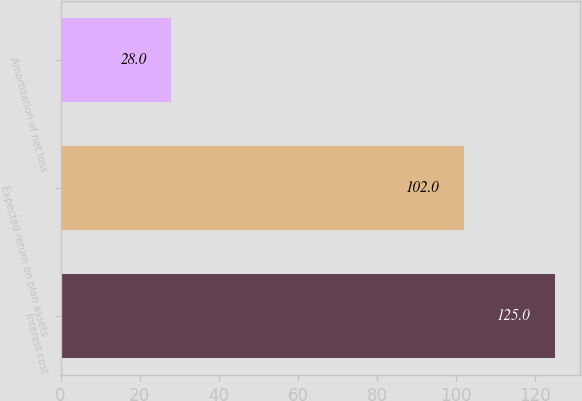Convert chart to OTSL. <chart><loc_0><loc_0><loc_500><loc_500><bar_chart><fcel>Interest cost<fcel>Expected return on plan assets<fcel>Amortization of net loss<nl><fcel>125<fcel>102<fcel>28<nl></chart> 